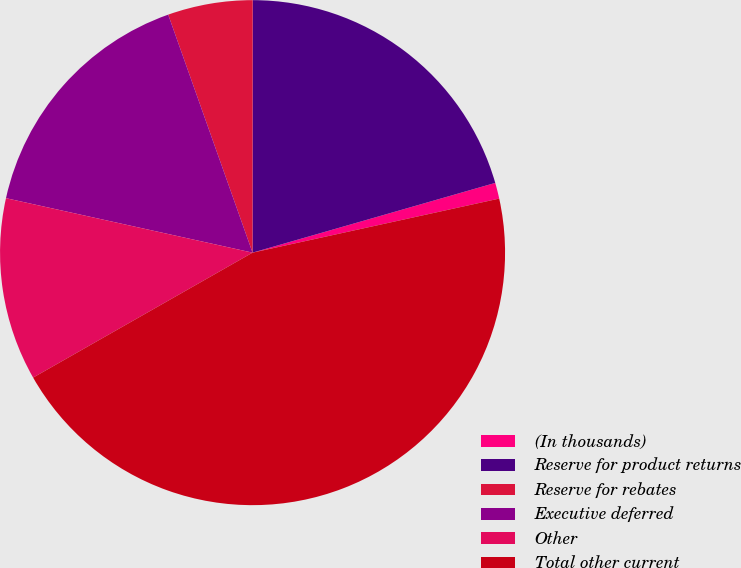Convert chart to OTSL. <chart><loc_0><loc_0><loc_500><loc_500><pie_chart><fcel>(In thousands)<fcel>Reserve for product returns<fcel>Reserve for rebates<fcel>Executive deferred<fcel>Other<fcel>Total other current<nl><fcel>1.02%<fcel>20.54%<fcel>5.43%<fcel>16.12%<fcel>11.7%<fcel>45.2%<nl></chart> 